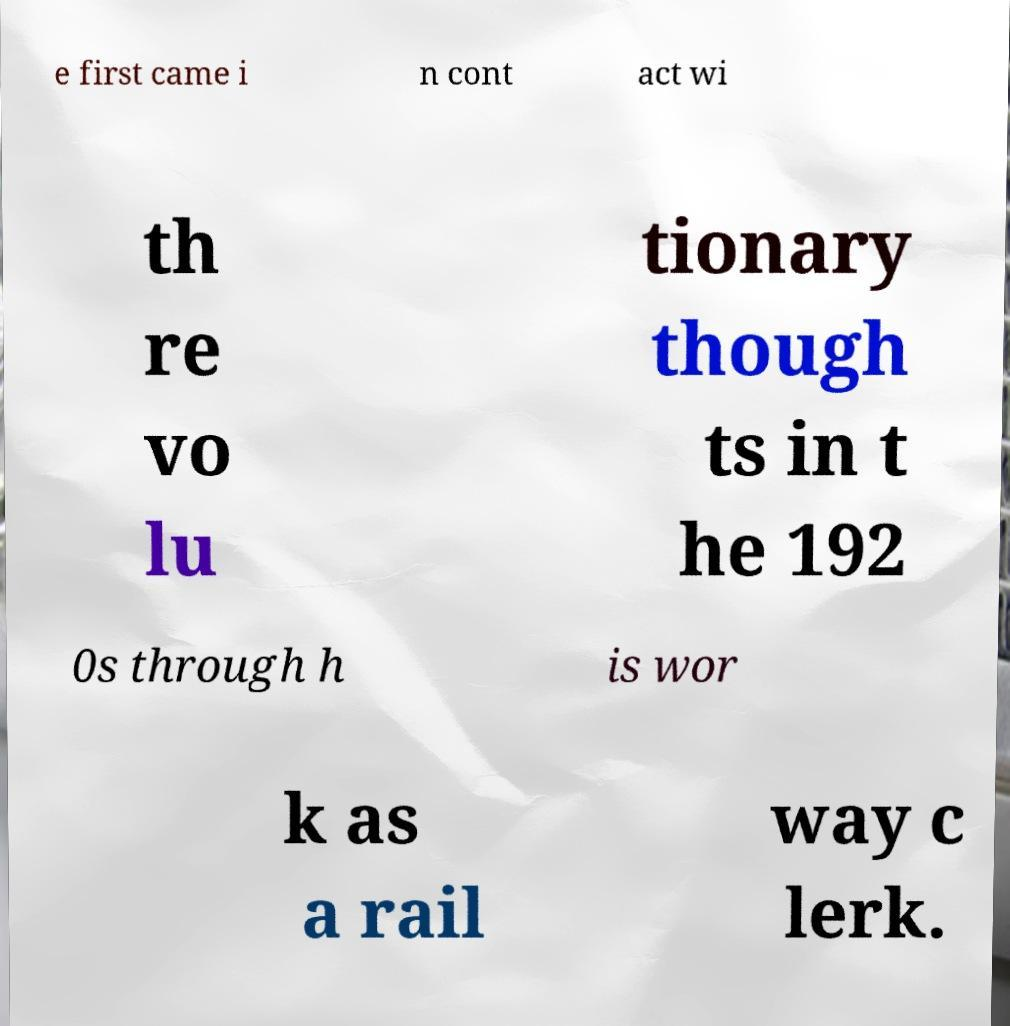Could you assist in decoding the text presented in this image and type it out clearly? e first came i n cont act wi th re vo lu tionary though ts in t he 192 0s through h is wor k as a rail way c lerk. 